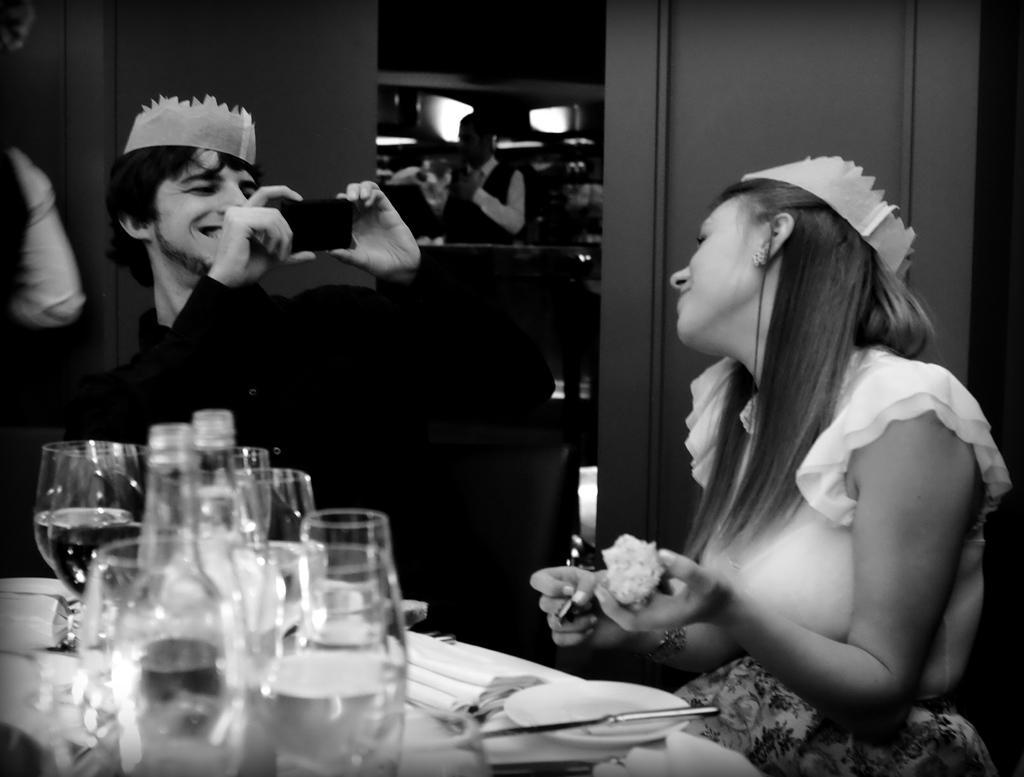Could you give a brief overview of what you see in this image? In this image we can see woman sitting near the table and a man holding a mobile phone in his hands. We can see glasses, bottles, plates and knife on the table. In the background we can see people. 